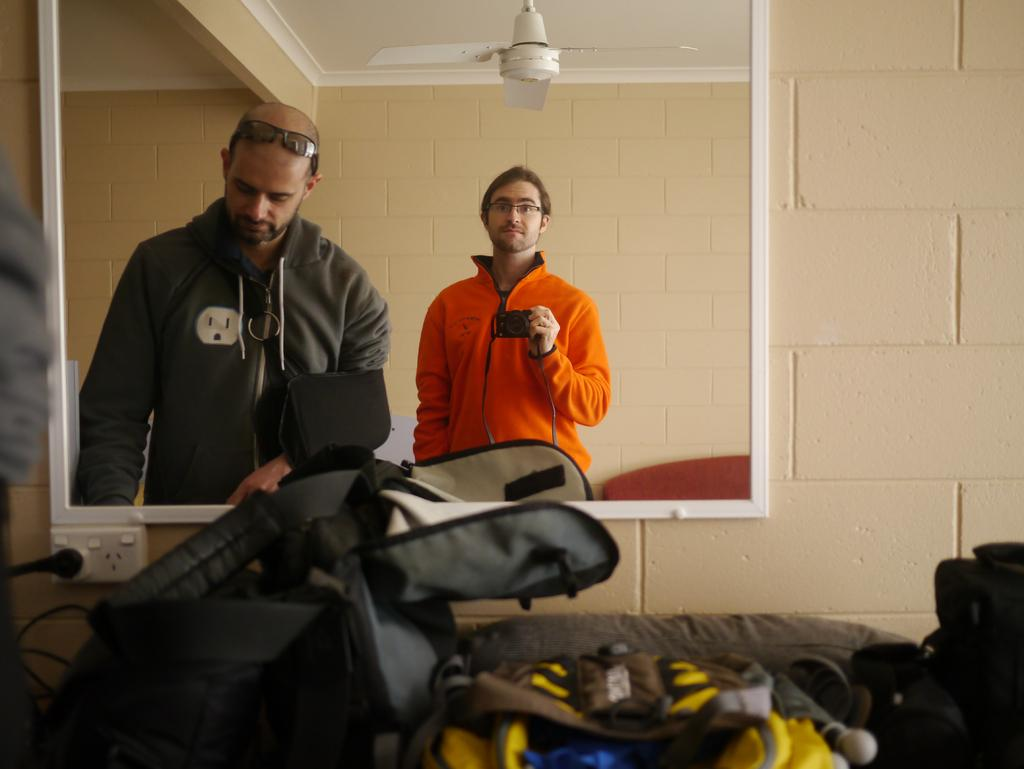What objects can be seen in the image? There are bags, a switch board, and a mirror on a wall in the image. What is the purpose of the switch board? The switch board is likely used for controlling electrical devices. What can be seen in the mirror in the image? Two people are visible in the mirror, and one person is holding a camera. What is the position of the fan in the image? The fan is visible at the top of the image. What type of cracker is being used to take the picture in the image? There is no cracker present in the image; one person is holding a camera in the mirror. How does the person holding the camera feel shame in the image? There is no indication of shame in the image; the person is simply holding a camera. 